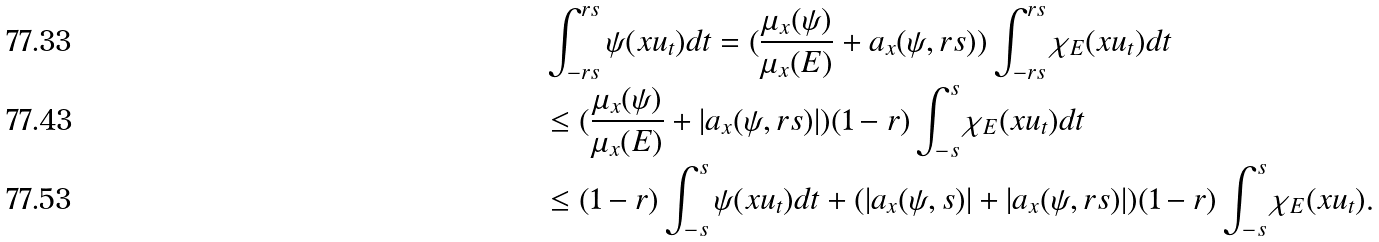<formula> <loc_0><loc_0><loc_500><loc_500>& \int _ { - r s } ^ { r s } \psi ( x u _ { t } ) d t = ( \frac { \mu _ { x } ( \psi ) } { \mu _ { x } ( E ) } + a _ { x } ( \psi , r s ) ) \int _ { - r s } ^ { r s } \chi _ { E } ( x u _ { t } ) d t \\ & \leq ( \frac { \mu _ { x } ( \psi ) } { \mu _ { x } ( E ) } + | a _ { x } ( \psi , r s ) | ) ( 1 - r ) \int _ { - s } ^ { s } \chi _ { E } ( x u _ { t } ) d t \\ & \leq ( 1 - r ) \int _ { - s } ^ { s } \psi ( x u _ { t } ) d t + ( | a _ { x } ( \psi , s ) | + | a _ { x } ( \psi , r s ) | ) ( 1 - r ) \int _ { - s } ^ { s } \chi _ { E } ( x u _ { t } ) .</formula> 